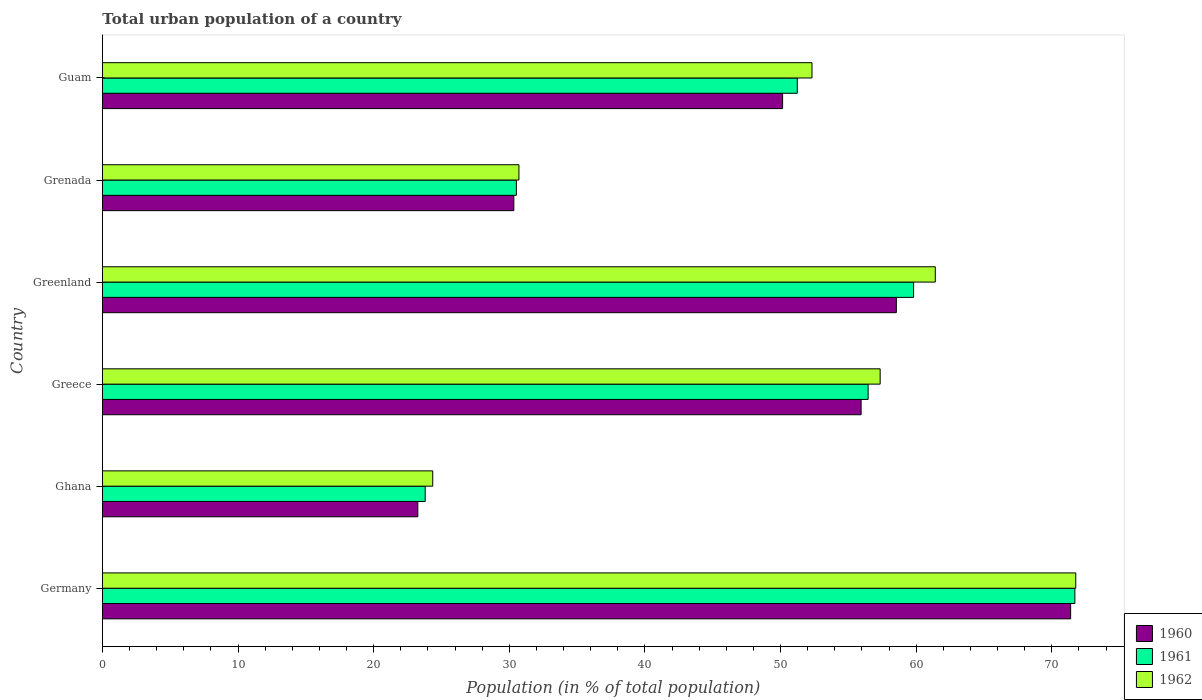Are the number of bars per tick equal to the number of legend labels?
Keep it short and to the point. Yes. Are the number of bars on each tick of the Y-axis equal?
Keep it short and to the point. Yes. How many bars are there on the 3rd tick from the top?
Ensure brevity in your answer.  3. What is the label of the 2nd group of bars from the top?
Your answer should be very brief. Grenada. What is the urban population in 1961 in Ghana?
Give a very brief answer. 23.8. Across all countries, what is the maximum urban population in 1961?
Make the answer very short. 71.7. Across all countries, what is the minimum urban population in 1961?
Your answer should be compact. 23.8. What is the total urban population in 1961 in the graph?
Make the answer very short. 293.5. What is the difference between the urban population in 1961 in Greece and that in Greenland?
Your answer should be very brief. -3.35. What is the difference between the urban population in 1962 in Greenland and the urban population in 1961 in Germany?
Keep it short and to the point. -10.29. What is the average urban population in 1960 per country?
Your response must be concise. 48.26. What is the difference between the urban population in 1960 and urban population in 1962 in Germany?
Ensure brevity in your answer.  -0.38. In how many countries, is the urban population in 1961 greater than 28 %?
Ensure brevity in your answer.  5. What is the ratio of the urban population in 1962 in Ghana to that in Greenland?
Your answer should be very brief. 0.4. Is the urban population in 1961 in Germany less than that in Ghana?
Provide a succinct answer. No. What is the difference between the highest and the second highest urban population in 1960?
Provide a short and direct response. 12.85. What is the difference between the highest and the lowest urban population in 1960?
Offer a very short reply. 48.13. Is the sum of the urban population in 1961 in Greece and Guam greater than the maximum urban population in 1960 across all countries?
Give a very brief answer. Yes. What does the 2nd bar from the top in Guam represents?
Offer a terse response. 1961. Is it the case that in every country, the sum of the urban population in 1960 and urban population in 1961 is greater than the urban population in 1962?
Provide a succinct answer. Yes. How many bars are there?
Offer a terse response. 18. How many countries are there in the graph?
Your answer should be very brief. 6. What is the difference between two consecutive major ticks on the X-axis?
Give a very brief answer. 10. Does the graph contain any zero values?
Provide a succinct answer. No. Does the graph contain grids?
Give a very brief answer. No. Where does the legend appear in the graph?
Provide a succinct answer. Bottom right. How many legend labels are there?
Give a very brief answer. 3. What is the title of the graph?
Provide a short and direct response. Total urban population of a country. What is the label or title of the X-axis?
Keep it short and to the point. Population (in % of total population). What is the label or title of the Y-axis?
Your response must be concise. Country. What is the Population (in % of total population) of 1960 in Germany?
Offer a terse response. 71.38. What is the Population (in % of total population) in 1961 in Germany?
Provide a succinct answer. 71.7. What is the Population (in % of total population) in 1962 in Germany?
Your response must be concise. 71.76. What is the Population (in % of total population) of 1960 in Ghana?
Ensure brevity in your answer.  23.25. What is the Population (in % of total population) of 1961 in Ghana?
Offer a very short reply. 23.8. What is the Population (in % of total population) in 1962 in Ghana?
Ensure brevity in your answer.  24.35. What is the Population (in % of total population) of 1960 in Greece?
Ensure brevity in your answer.  55.94. What is the Population (in % of total population) of 1961 in Greece?
Your answer should be compact. 56.45. What is the Population (in % of total population) in 1962 in Greece?
Offer a very short reply. 57.34. What is the Population (in % of total population) of 1960 in Greenland?
Offer a terse response. 58.53. What is the Population (in % of total population) in 1961 in Greenland?
Offer a very short reply. 59.81. What is the Population (in % of total population) in 1962 in Greenland?
Provide a succinct answer. 61.41. What is the Population (in % of total population) in 1960 in Grenada?
Provide a short and direct response. 30.33. What is the Population (in % of total population) of 1961 in Grenada?
Offer a very short reply. 30.52. What is the Population (in % of total population) in 1962 in Grenada?
Offer a terse response. 30.71. What is the Population (in % of total population) of 1960 in Guam?
Keep it short and to the point. 50.15. What is the Population (in % of total population) of 1961 in Guam?
Provide a short and direct response. 51.23. What is the Population (in % of total population) of 1962 in Guam?
Provide a short and direct response. 52.31. Across all countries, what is the maximum Population (in % of total population) in 1960?
Give a very brief answer. 71.38. Across all countries, what is the maximum Population (in % of total population) of 1961?
Give a very brief answer. 71.7. Across all countries, what is the maximum Population (in % of total population) in 1962?
Your answer should be very brief. 71.76. Across all countries, what is the minimum Population (in % of total population) of 1960?
Give a very brief answer. 23.25. Across all countries, what is the minimum Population (in % of total population) in 1961?
Give a very brief answer. 23.8. Across all countries, what is the minimum Population (in % of total population) of 1962?
Your answer should be very brief. 24.35. What is the total Population (in % of total population) in 1960 in the graph?
Your response must be concise. 289.58. What is the total Population (in % of total population) in 1961 in the graph?
Your answer should be compact. 293.5. What is the total Population (in % of total population) of 1962 in the graph?
Your answer should be compact. 297.88. What is the difference between the Population (in % of total population) in 1960 in Germany and that in Ghana?
Keep it short and to the point. 48.13. What is the difference between the Population (in % of total population) of 1961 in Germany and that in Ghana?
Offer a terse response. 47.9. What is the difference between the Population (in % of total population) in 1962 in Germany and that in Ghana?
Provide a short and direct response. 47.41. What is the difference between the Population (in % of total population) in 1960 in Germany and that in Greece?
Provide a succinct answer. 15.45. What is the difference between the Population (in % of total population) of 1961 in Germany and that in Greece?
Provide a short and direct response. 15.24. What is the difference between the Population (in % of total population) in 1962 in Germany and that in Greece?
Provide a succinct answer. 14.42. What is the difference between the Population (in % of total population) of 1960 in Germany and that in Greenland?
Provide a succinct answer. 12.85. What is the difference between the Population (in % of total population) of 1961 in Germany and that in Greenland?
Give a very brief answer. 11.89. What is the difference between the Population (in % of total population) of 1962 in Germany and that in Greenland?
Give a very brief answer. 10.36. What is the difference between the Population (in % of total population) of 1960 in Germany and that in Grenada?
Your answer should be very brief. 41.05. What is the difference between the Population (in % of total population) of 1961 in Germany and that in Grenada?
Ensure brevity in your answer.  41.18. What is the difference between the Population (in % of total population) of 1962 in Germany and that in Grenada?
Offer a very short reply. 41.05. What is the difference between the Population (in % of total population) in 1960 in Germany and that in Guam?
Your answer should be very brief. 21.24. What is the difference between the Population (in % of total population) of 1961 in Germany and that in Guam?
Offer a very short reply. 20.47. What is the difference between the Population (in % of total population) in 1962 in Germany and that in Guam?
Provide a succinct answer. 19.45. What is the difference between the Population (in % of total population) of 1960 in Ghana and that in Greece?
Keep it short and to the point. -32.68. What is the difference between the Population (in % of total population) in 1961 in Ghana and that in Greece?
Offer a terse response. -32.66. What is the difference between the Population (in % of total population) of 1962 in Ghana and that in Greece?
Provide a short and direct response. -32.99. What is the difference between the Population (in % of total population) in 1960 in Ghana and that in Greenland?
Your answer should be very brief. -35.28. What is the difference between the Population (in % of total population) in 1961 in Ghana and that in Greenland?
Provide a succinct answer. -36.01. What is the difference between the Population (in % of total population) in 1962 in Ghana and that in Greenland?
Give a very brief answer. -37.05. What is the difference between the Population (in % of total population) of 1960 in Ghana and that in Grenada?
Ensure brevity in your answer.  -7.08. What is the difference between the Population (in % of total population) in 1961 in Ghana and that in Grenada?
Your answer should be very brief. -6.72. What is the difference between the Population (in % of total population) in 1962 in Ghana and that in Grenada?
Your response must be concise. -6.36. What is the difference between the Population (in % of total population) of 1960 in Ghana and that in Guam?
Your answer should be very brief. -26.89. What is the difference between the Population (in % of total population) in 1961 in Ghana and that in Guam?
Make the answer very short. -27.43. What is the difference between the Population (in % of total population) of 1962 in Ghana and that in Guam?
Your answer should be very brief. -27.96. What is the difference between the Population (in % of total population) in 1960 in Greece and that in Greenland?
Give a very brief answer. -2.6. What is the difference between the Population (in % of total population) of 1961 in Greece and that in Greenland?
Offer a very short reply. -3.35. What is the difference between the Population (in % of total population) in 1962 in Greece and that in Greenland?
Your answer should be compact. -4.07. What is the difference between the Population (in % of total population) in 1960 in Greece and that in Grenada?
Offer a terse response. 25.6. What is the difference between the Population (in % of total population) in 1961 in Greece and that in Grenada?
Your answer should be very brief. 25.93. What is the difference between the Population (in % of total population) of 1962 in Greece and that in Grenada?
Provide a succinct answer. 26.63. What is the difference between the Population (in % of total population) in 1960 in Greece and that in Guam?
Provide a succinct answer. 5.79. What is the difference between the Population (in % of total population) of 1961 in Greece and that in Guam?
Give a very brief answer. 5.22. What is the difference between the Population (in % of total population) in 1962 in Greece and that in Guam?
Make the answer very short. 5.03. What is the difference between the Population (in % of total population) of 1960 in Greenland and that in Grenada?
Give a very brief answer. 28.2. What is the difference between the Population (in % of total population) in 1961 in Greenland and that in Grenada?
Keep it short and to the point. 29.29. What is the difference between the Population (in % of total population) of 1962 in Greenland and that in Grenada?
Provide a succinct answer. 30.7. What is the difference between the Population (in % of total population) in 1960 in Greenland and that in Guam?
Give a very brief answer. 8.39. What is the difference between the Population (in % of total population) in 1961 in Greenland and that in Guam?
Your answer should be very brief. 8.58. What is the difference between the Population (in % of total population) in 1962 in Greenland and that in Guam?
Offer a terse response. 9.09. What is the difference between the Population (in % of total population) in 1960 in Grenada and that in Guam?
Provide a succinct answer. -19.82. What is the difference between the Population (in % of total population) of 1961 in Grenada and that in Guam?
Make the answer very short. -20.71. What is the difference between the Population (in % of total population) in 1962 in Grenada and that in Guam?
Give a very brief answer. -21.61. What is the difference between the Population (in % of total population) of 1960 in Germany and the Population (in % of total population) of 1961 in Ghana?
Provide a succinct answer. 47.59. What is the difference between the Population (in % of total population) in 1960 in Germany and the Population (in % of total population) in 1962 in Ghana?
Provide a short and direct response. 47.03. What is the difference between the Population (in % of total population) in 1961 in Germany and the Population (in % of total population) in 1962 in Ghana?
Provide a short and direct response. 47.34. What is the difference between the Population (in % of total population) in 1960 in Germany and the Population (in % of total population) in 1961 in Greece?
Offer a terse response. 14.93. What is the difference between the Population (in % of total population) of 1960 in Germany and the Population (in % of total population) of 1962 in Greece?
Provide a short and direct response. 14.04. What is the difference between the Population (in % of total population) of 1961 in Germany and the Population (in % of total population) of 1962 in Greece?
Provide a succinct answer. 14.36. What is the difference between the Population (in % of total population) in 1960 in Germany and the Population (in % of total population) in 1961 in Greenland?
Give a very brief answer. 11.58. What is the difference between the Population (in % of total population) in 1960 in Germany and the Population (in % of total population) in 1962 in Greenland?
Offer a very short reply. 9.98. What is the difference between the Population (in % of total population) in 1961 in Germany and the Population (in % of total population) in 1962 in Greenland?
Keep it short and to the point. 10.29. What is the difference between the Population (in % of total population) of 1960 in Germany and the Population (in % of total population) of 1961 in Grenada?
Ensure brevity in your answer.  40.87. What is the difference between the Population (in % of total population) of 1960 in Germany and the Population (in % of total population) of 1962 in Grenada?
Keep it short and to the point. 40.68. What is the difference between the Population (in % of total population) in 1961 in Germany and the Population (in % of total population) in 1962 in Grenada?
Keep it short and to the point. 40.99. What is the difference between the Population (in % of total population) in 1960 in Germany and the Population (in % of total population) in 1961 in Guam?
Ensure brevity in your answer.  20.15. What is the difference between the Population (in % of total population) in 1960 in Germany and the Population (in % of total population) in 1962 in Guam?
Ensure brevity in your answer.  19.07. What is the difference between the Population (in % of total population) in 1961 in Germany and the Population (in % of total population) in 1962 in Guam?
Your answer should be compact. 19.38. What is the difference between the Population (in % of total population) of 1960 in Ghana and the Population (in % of total population) of 1961 in Greece?
Give a very brief answer. -33.2. What is the difference between the Population (in % of total population) in 1960 in Ghana and the Population (in % of total population) in 1962 in Greece?
Make the answer very short. -34.09. What is the difference between the Population (in % of total population) of 1961 in Ghana and the Population (in % of total population) of 1962 in Greece?
Make the answer very short. -33.54. What is the difference between the Population (in % of total population) of 1960 in Ghana and the Population (in % of total population) of 1961 in Greenland?
Make the answer very short. -36.55. What is the difference between the Population (in % of total population) of 1960 in Ghana and the Population (in % of total population) of 1962 in Greenland?
Make the answer very short. -38.15. What is the difference between the Population (in % of total population) of 1961 in Ghana and the Population (in % of total population) of 1962 in Greenland?
Offer a terse response. -37.61. What is the difference between the Population (in % of total population) of 1960 in Ghana and the Population (in % of total population) of 1961 in Grenada?
Offer a very short reply. -7.27. What is the difference between the Population (in % of total population) in 1960 in Ghana and the Population (in % of total population) in 1962 in Grenada?
Provide a short and direct response. -7.46. What is the difference between the Population (in % of total population) of 1961 in Ghana and the Population (in % of total population) of 1962 in Grenada?
Make the answer very short. -6.91. What is the difference between the Population (in % of total population) in 1960 in Ghana and the Population (in % of total population) in 1961 in Guam?
Your answer should be very brief. -27.98. What is the difference between the Population (in % of total population) of 1960 in Ghana and the Population (in % of total population) of 1962 in Guam?
Your response must be concise. -29.06. What is the difference between the Population (in % of total population) of 1961 in Ghana and the Population (in % of total population) of 1962 in Guam?
Offer a terse response. -28.52. What is the difference between the Population (in % of total population) of 1960 in Greece and the Population (in % of total population) of 1961 in Greenland?
Offer a terse response. -3.87. What is the difference between the Population (in % of total population) of 1960 in Greece and the Population (in % of total population) of 1962 in Greenland?
Offer a terse response. -5.47. What is the difference between the Population (in % of total population) of 1961 in Greece and the Population (in % of total population) of 1962 in Greenland?
Ensure brevity in your answer.  -4.95. What is the difference between the Population (in % of total population) in 1960 in Greece and the Population (in % of total population) in 1961 in Grenada?
Give a very brief answer. 25.42. What is the difference between the Population (in % of total population) of 1960 in Greece and the Population (in % of total population) of 1962 in Grenada?
Your answer should be very brief. 25.23. What is the difference between the Population (in % of total population) of 1961 in Greece and the Population (in % of total population) of 1962 in Grenada?
Your answer should be compact. 25.75. What is the difference between the Population (in % of total population) of 1960 in Greece and the Population (in % of total population) of 1961 in Guam?
Offer a very short reply. 4.71. What is the difference between the Population (in % of total population) in 1960 in Greece and the Population (in % of total population) in 1962 in Guam?
Offer a very short reply. 3.62. What is the difference between the Population (in % of total population) of 1961 in Greece and the Population (in % of total population) of 1962 in Guam?
Offer a terse response. 4.14. What is the difference between the Population (in % of total population) in 1960 in Greenland and the Population (in % of total population) in 1961 in Grenada?
Provide a succinct answer. 28.02. What is the difference between the Population (in % of total population) of 1960 in Greenland and the Population (in % of total population) of 1962 in Grenada?
Make the answer very short. 27.83. What is the difference between the Population (in % of total population) in 1961 in Greenland and the Population (in % of total population) in 1962 in Grenada?
Your answer should be very brief. 29.1. What is the difference between the Population (in % of total population) of 1960 in Greenland and the Population (in % of total population) of 1961 in Guam?
Offer a terse response. 7.3. What is the difference between the Population (in % of total population) in 1960 in Greenland and the Population (in % of total population) in 1962 in Guam?
Offer a terse response. 6.22. What is the difference between the Population (in % of total population) in 1961 in Greenland and the Population (in % of total population) in 1962 in Guam?
Your answer should be compact. 7.49. What is the difference between the Population (in % of total population) of 1960 in Grenada and the Population (in % of total population) of 1961 in Guam?
Ensure brevity in your answer.  -20.9. What is the difference between the Population (in % of total population) in 1960 in Grenada and the Population (in % of total population) in 1962 in Guam?
Your response must be concise. -21.98. What is the difference between the Population (in % of total population) in 1961 in Grenada and the Population (in % of total population) in 1962 in Guam?
Give a very brief answer. -21.8. What is the average Population (in % of total population) in 1960 per country?
Your response must be concise. 48.26. What is the average Population (in % of total population) in 1961 per country?
Your response must be concise. 48.92. What is the average Population (in % of total population) in 1962 per country?
Your answer should be very brief. 49.65. What is the difference between the Population (in % of total population) in 1960 and Population (in % of total population) in 1961 in Germany?
Give a very brief answer. -0.31. What is the difference between the Population (in % of total population) in 1960 and Population (in % of total population) in 1962 in Germany?
Your response must be concise. -0.38. What is the difference between the Population (in % of total population) in 1961 and Population (in % of total population) in 1962 in Germany?
Keep it short and to the point. -0.07. What is the difference between the Population (in % of total population) of 1960 and Population (in % of total population) of 1961 in Ghana?
Provide a short and direct response. -0.55. What is the difference between the Population (in % of total population) of 1961 and Population (in % of total population) of 1962 in Ghana?
Your answer should be compact. -0.56. What is the difference between the Population (in % of total population) of 1960 and Population (in % of total population) of 1961 in Greece?
Offer a very short reply. -0.52. What is the difference between the Population (in % of total population) of 1960 and Population (in % of total population) of 1962 in Greece?
Keep it short and to the point. -1.4. What is the difference between the Population (in % of total population) in 1961 and Population (in % of total population) in 1962 in Greece?
Your response must be concise. -0.89. What is the difference between the Population (in % of total population) in 1960 and Population (in % of total population) in 1961 in Greenland?
Make the answer very short. -1.27. What is the difference between the Population (in % of total population) of 1960 and Population (in % of total population) of 1962 in Greenland?
Keep it short and to the point. -2.87. What is the difference between the Population (in % of total population) in 1961 and Population (in % of total population) in 1962 in Greenland?
Offer a terse response. -1.6. What is the difference between the Population (in % of total population) in 1960 and Population (in % of total population) in 1961 in Grenada?
Ensure brevity in your answer.  -0.19. What is the difference between the Population (in % of total population) in 1960 and Population (in % of total population) in 1962 in Grenada?
Give a very brief answer. -0.38. What is the difference between the Population (in % of total population) in 1961 and Population (in % of total population) in 1962 in Grenada?
Provide a short and direct response. -0.19. What is the difference between the Population (in % of total population) in 1960 and Population (in % of total population) in 1961 in Guam?
Your response must be concise. -1.08. What is the difference between the Population (in % of total population) of 1960 and Population (in % of total population) of 1962 in Guam?
Make the answer very short. -2.17. What is the difference between the Population (in % of total population) in 1961 and Population (in % of total population) in 1962 in Guam?
Your response must be concise. -1.08. What is the ratio of the Population (in % of total population) in 1960 in Germany to that in Ghana?
Your answer should be compact. 3.07. What is the ratio of the Population (in % of total population) of 1961 in Germany to that in Ghana?
Give a very brief answer. 3.01. What is the ratio of the Population (in % of total population) in 1962 in Germany to that in Ghana?
Provide a short and direct response. 2.95. What is the ratio of the Population (in % of total population) of 1960 in Germany to that in Greece?
Your answer should be very brief. 1.28. What is the ratio of the Population (in % of total population) of 1961 in Germany to that in Greece?
Provide a short and direct response. 1.27. What is the ratio of the Population (in % of total population) in 1962 in Germany to that in Greece?
Keep it short and to the point. 1.25. What is the ratio of the Population (in % of total population) in 1960 in Germany to that in Greenland?
Provide a succinct answer. 1.22. What is the ratio of the Population (in % of total population) of 1961 in Germany to that in Greenland?
Keep it short and to the point. 1.2. What is the ratio of the Population (in % of total population) of 1962 in Germany to that in Greenland?
Make the answer very short. 1.17. What is the ratio of the Population (in % of total population) of 1960 in Germany to that in Grenada?
Offer a very short reply. 2.35. What is the ratio of the Population (in % of total population) in 1961 in Germany to that in Grenada?
Your answer should be compact. 2.35. What is the ratio of the Population (in % of total population) in 1962 in Germany to that in Grenada?
Make the answer very short. 2.34. What is the ratio of the Population (in % of total population) in 1960 in Germany to that in Guam?
Give a very brief answer. 1.42. What is the ratio of the Population (in % of total population) of 1961 in Germany to that in Guam?
Offer a very short reply. 1.4. What is the ratio of the Population (in % of total population) in 1962 in Germany to that in Guam?
Your response must be concise. 1.37. What is the ratio of the Population (in % of total population) in 1960 in Ghana to that in Greece?
Your answer should be compact. 0.42. What is the ratio of the Population (in % of total population) of 1961 in Ghana to that in Greece?
Ensure brevity in your answer.  0.42. What is the ratio of the Population (in % of total population) in 1962 in Ghana to that in Greece?
Give a very brief answer. 0.42. What is the ratio of the Population (in % of total population) in 1960 in Ghana to that in Greenland?
Your answer should be compact. 0.4. What is the ratio of the Population (in % of total population) of 1961 in Ghana to that in Greenland?
Offer a terse response. 0.4. What is the ratio of the Population (in % of total population) of 1962 in Ghana to that in Greenland?
Ensure brevity in your answer.  0.4. What is the ratio of the Population (in % of total population) in 1960 in Ghana to that in Grenada?
Offer a very short reply. 0.77. What is the ratio of the Population (in % of total population) of 1961 in Ghana to that in Grenada?
Provide a short and direct response. 0.78. What is the ratio of the Population (in % of total population) of 1962 in Ghana to that in Grenada?
Ensure brevity in your answer.  0.79. What is the ratio of the Population (in % of total population) of 1960 in Ghana to that in Guam?
Provide a short and direct response. 0.46. What is the ratio of the Population (in % of total population) in 1961 in Ghana to that in Guam?
Keep it short and to the point. 0.46. What is the ratio of the Population (in % of total population) in 1962 in Ghana to that in Guam?
Your response must be concise. 0.47. What is the ratio of the Population (in % of total population) of 1960 in Greece to that in Greenland?
Offer a terse response. 0.96. What is the ratio of the Population (in % of total population) in 1961 in Greece to that in Greenland?
Provide a short and direct response. 0.94. What is the ratio of the Population (in % of total population) in 1962 in Greece to that in Greenland?
Ensure brevity in your answer.  0.93. What is the ratio of the Population (in % of total population) of 1960 in Greece to that in Grenada?
Your answer should be very brief. 1.84. What is the ratio of the Population (in % of total population) in 1961 in Greece to that in Grenada?
Your answer should be compact. 1.85. What is the ratio of the Population (in % of total population) of 1962 in Greece to that in Grenada?
Give a very brief answer. 1.87. What is the ratio of the Population (in % of total population) in 1960 in Greece to that in Guam?
Offer a very short reply. 1.12. What is the ratio of the Population (in % of total population) of 1961 in Greece to that in Guam?
Ensure brevity in your answer.  1.1. What is the ratio of the Population (in % of total population) in 1962 in Greece to that in Guam?
Your response must be concise. 1.1. What is the ratio of the Population (in % of total population) in 1960 in Greenland to that in Grenada?
Give a very brief answer. 1.93. What is the ratio of the Population (in % of total population) in 1961 in Greenland to that in Grenada?
Offer a very short reply. 1.96. What is the ratio of the Population (in % of total population) in 1962 in Greenland to that in Grenada?
Your response must be concise. 2. What is the ratio of the Population (in % of total population) in 1960 in Greenland to that in Guam?
Provide a succinct answer. 1.17. What is the ratio of the Population (in % of total population) of 1961 in Greenland to that in Guam?
Ensure brevity in your answer.  1.17. What is the ratio of the Population (in % of total population) of 1962 in Greenland to that in Guam?
Keep it short and to the point. 1.17. What is the ratio of the Population (in % of total population) of 1960 in Grenada to that in Guam?
Ensure brevity in your answer.  0.6. What is the ratio of the Population (in % of total population) of 1961 in Grenada to that in Guam?
Provide a succinct answer. 0.6. What is the ratio of the Population (in % of total population) of 1962 in Grenada to that in Guam?
Provide a succinct answer. 0.59. What is the difference between the highest and the second highest Population (in % of total population) of 1960?
Ensure brevity in your answer.  12.85. What is the difference between the highest and the second highest Population (in % of total population) in 1961?
Offer a very short reply. 11.89. What is the difference between the highest and the second highest Population (in % of total population) in 1962?
Make the answer very short. 10.36. What is the difference between the highest and the lowest Population (in % of total population) of 1960?
Your answer should be compact. 48.13. What is the difference between the highest and the lowest Population (in % of total population) in 1961?
Provide a succinct answer. 47.9. What is the difference between the highest and the lowest Population (in % of total population) in 1962?
Your response must be concise. 47.41. 